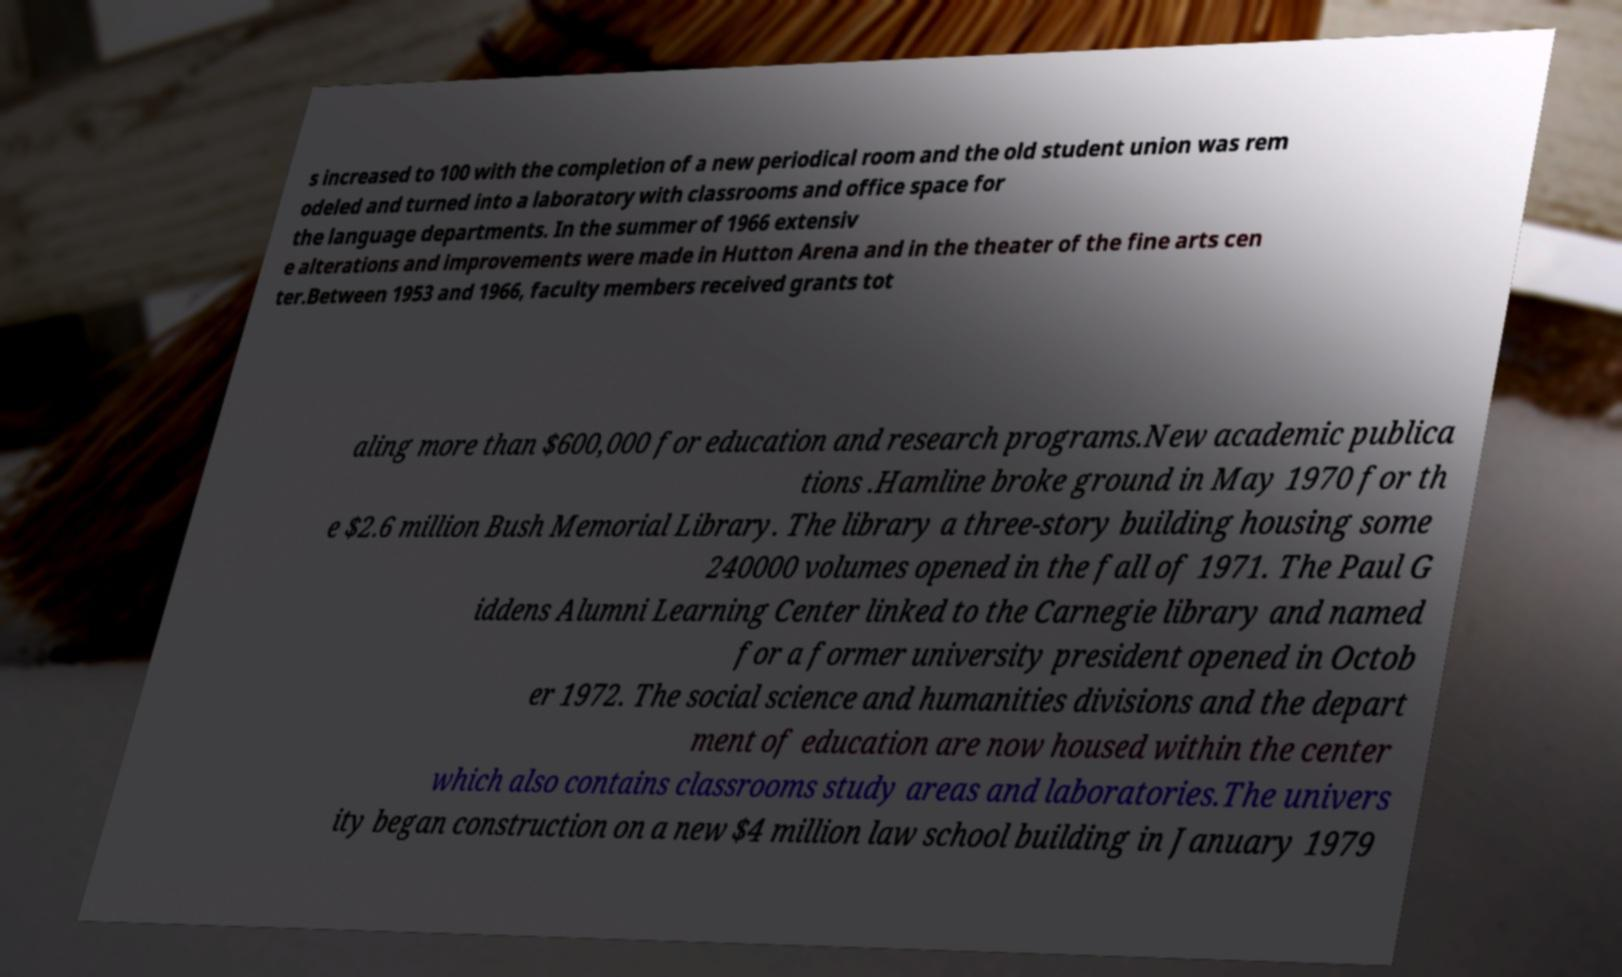Can you read and provide the text displayed in the image?This photo seems to have some interesting text. Can you extract and type it out for me? s increased to 100 with the completion of a new periodical room and the old student union was rem odeled and turned into a laboratory with classrooms and office space for the language departments. In the summer of 1966 extensiv e alterations and improvements were made in Hutton Arena and in the theater of the fine arts cen ter.Between 1953 and 1966, faculty members received grants tot aling more than $600,000 for education and research programs.New academic publica tions .Hamline broke ground in May 1970 for th e $2.6 million Bush Memorial Library. The library a three-story building housing some 240000 volumes opened in the fall of 1971. The Paul G iddens Alumni Learning Center linked to the Carnegie library and named for a former university president opened in Octob er 1972. The social science and humanities divisions and the depart ment of education are now housed within the center which also contains classrooms study areas and laboratories.The univers ity began construction on a new $4 million law school building in January 1979 